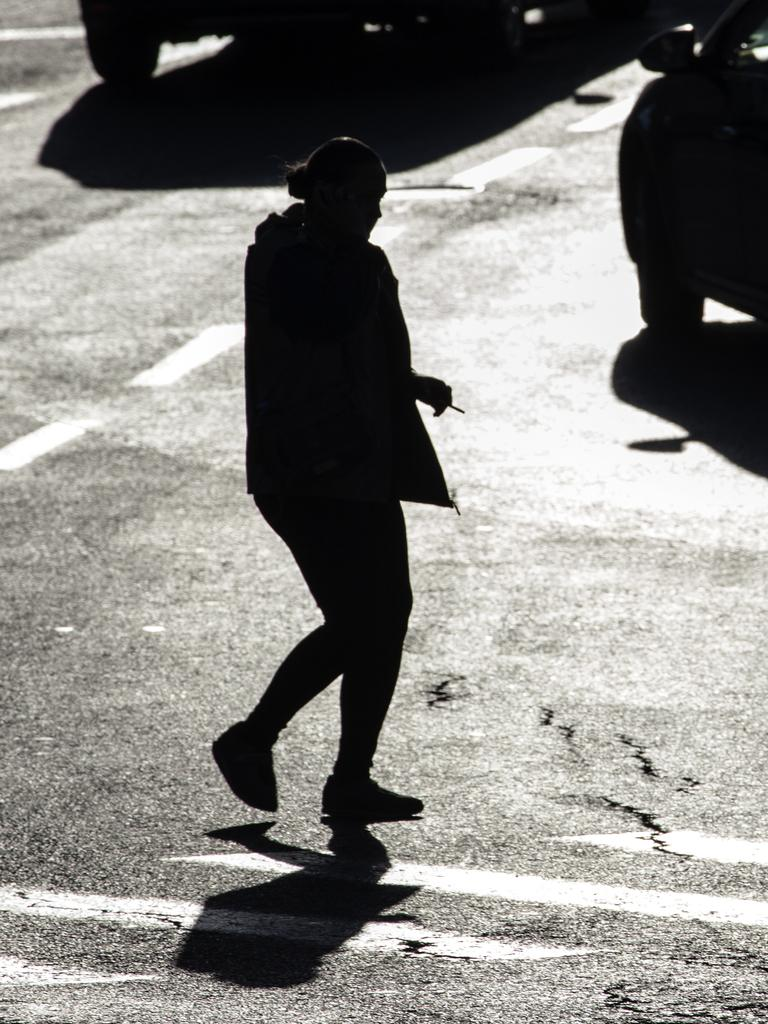What is the main subject of the image? There is a person walking in the image. Where is the person walking? The person is walking on a road. What else can be seen in the image? Vehicles are visible at the top of the image. What type of suit is the person wearing in the image? The person's clothing is not mentioned in the image, so it cannot be determined if they are wearing a suit or any other specific type of clothing. 